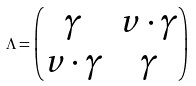<formula> <loc_0><loc_0><loc_500><loc_500>\Lambda = \begin{pmatrix} \gamma & v \cdot \gamma \\ v \cdot \gamma & \gamma \end{pmatrix}</formula> 